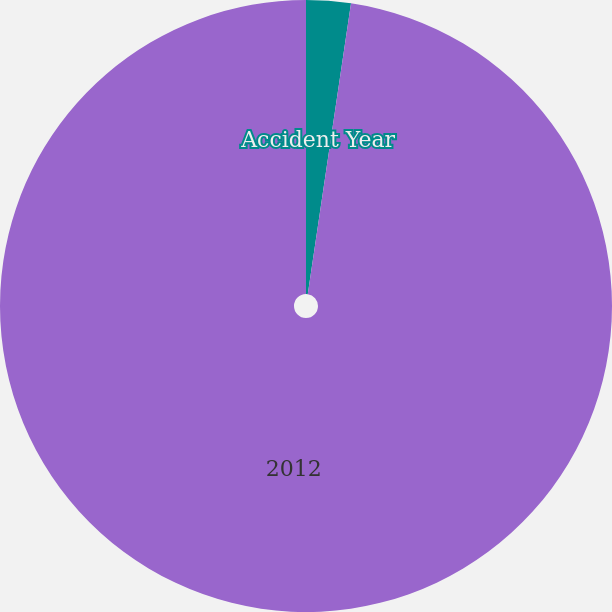<chart> <loc_0><loc_0><loc_500><loc_500><pie_chart><fcel>Accident Year<fcel>2012<nl><fcel>2.35%<fcel>97.65%<nl></chart> 